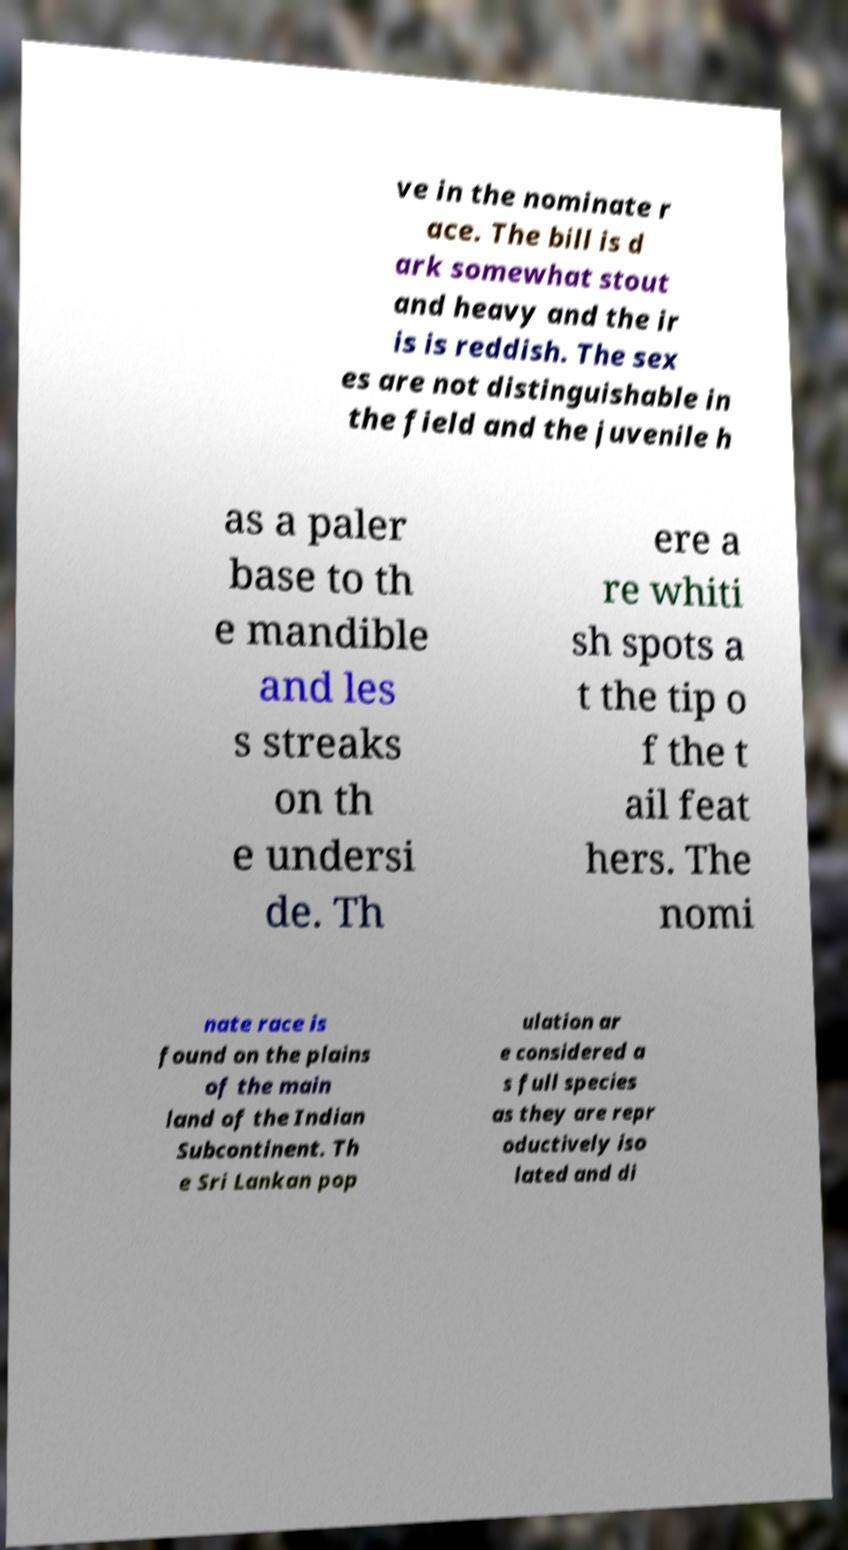Could you assist in decoding the text presented in this image and type it out clearly? ve in the nominate r ace. The bill is d ark somewhat stout and heavy and the ir is is reddish. The sex es are not distinguishable in the field and the juvenile h as a paler base to th e mandible and les s streaks on th e undersi de. Th ere a re whiti sh spots a t the tip o f the t ail feat hers. The nomi nate race is found on the plains of the main land of the Indian Subcontinent. Th e Sri Lankan pop ulation ar e considered a s full species as they are repr oductively iso lated and di 